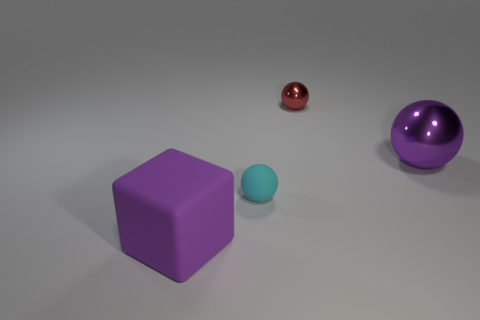Is the color of the small thing that is to the right of the tiny cyan object the same as the small matte ball?
Offer a very short reply. No. What number of objects are gray balls or purple things?
Provide a succinct answer. 2. The tiny object in front of the big purple shiny sphere is what color?
Make the answer very short. Cyan. Is the number of large purple spheres that are behind the small matte ball less than the number of large red spheres?
Provide a succinct answer. No. What size is the shiny ball that is the same color as the rubber block?
Give a very brief answer. Large. Are there any other things that are the same size as the purple ball?
Offer a terse response. Yes. Is the material of the cyan sphere the same as the big sphere?
Provide a succinct answer. No. What number of things are either objects that are in front of the small red thing or purple things that are to the left of the tiny cyan matte sphere?
Provide a succinct answer. 3. Are there any metallic things of the same size as the purple matte object?
Give a very brief answer. Yes. There is another tiny thing that is the same shape as the tiny red shiny thing; what color is it?
Provide a succinct answer. Cyan. 